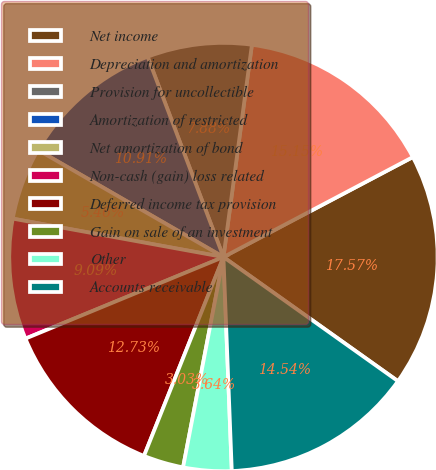<chart> <loc_0><loc_0><loc_500><loc_500><pie_chart><fcel>Net income<fcel>Depreciation and amortization<fcel>Provision for uncollectible<fcel>Amortization of restricted<fcel>Net amortization of bond<fcel>Non-cash (gain) loss related<fcel>Deferred income tax provision<fcel>Gain on sale of an investment<fcel>Other<fcel>Accounts receivable<nl><fcel>17.57%<fcel>15.15%<fcel>7.88%<fcel>10.91%<fcel>5.46%<fcel>9.09%<fcel>12.73%<fcel>3.03%<fcel>3.64%<fcel>14.54%<nl></chart> 